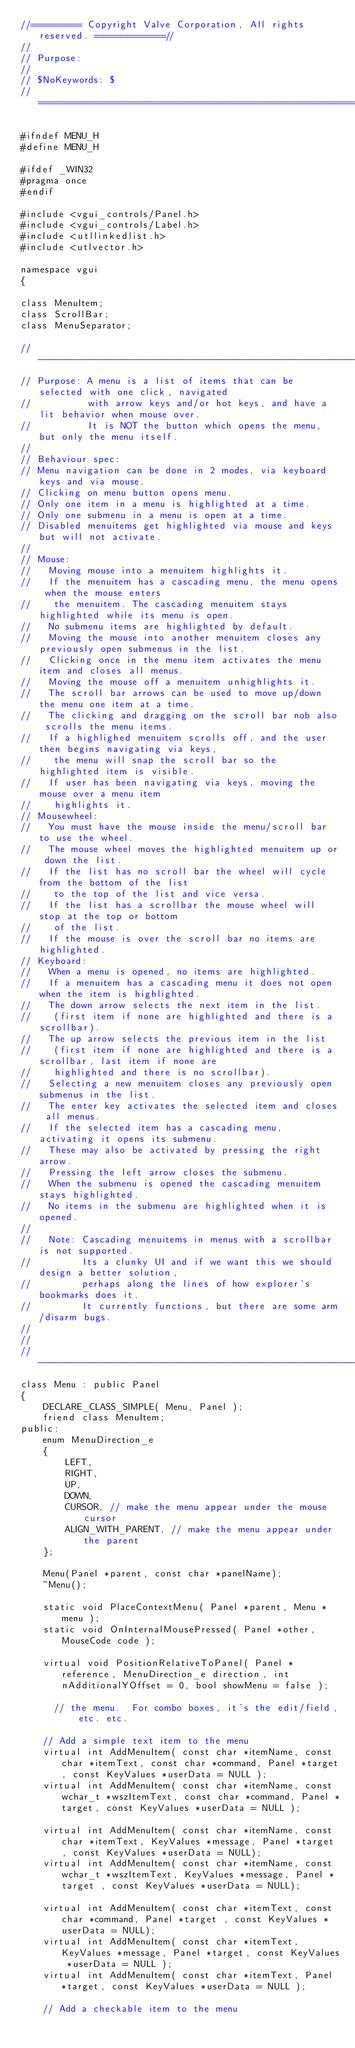Convert code to text. <code><loc_0><loc_0><loc_500><loc_500><_C_>//========= Copyright Valve Corporation, All rights reserved. ============//
//
// Purpose:
//
// $NoKeywords: $
//===========================================================================//

#ifndef MENU_H
#define MENU_H

#ifdef _WIN32
#pragma once
#endif

#include <vgui_controls/Panel.h>
#include <vgui_controls/Label.h>
#include <utllinkedlist.h>
#include <utlvector.h>

namespace vgui
{

class MenuItem;
class ScrollBar;
class MenuSeparator;

//-----------------------------------------------------------------------------
// Purpose: A menu is a list of items that can be selected with one click, navigated
//          with arrow keys and/or hot keys, and have a lit behavior when mouse over.
//          It is NOT the button which opens the menu, but only the menu itself.
//
// Behaviour spec:
// Menu navigation can be done in 2 modes, via keyboard keys and via mouse.
// Clicking on menu button opens menu.
// Only one item in a menu is highlighted at a time.
// Only one submenu in a menu is open at a time.
// Disabled menuitems get highlighted via mouse and keys but will not activate.
//
// Mouse:
//   Moving mouse into a menuitem highlights it.
//   If the menuitem has a cascading menu, the menu opens when the mouse enters
//    the menuitem. The cascading menuitem stays highlighted while its menu is open.
//   No submenu items are highlighted by default.
//   Moving the mouse into another menuitem closes any previously open submenus in the list.
//   Clicking once in the menu item activates the menu item and closes all menus.
//   Moving the mouse off a menuitem unhighlights it.
//   The scroll bar arrows can be used to move up/down the menu one item at a time.
//   The clicking and dragging on the scroll bar nob also scrolls the menu items.
//   If a highlighed menuitem scrolls off, and the user then begins navigating via keys,
//    the menu will snap the scroll bar so the highlighted item is visible.
//   If user has been navigating via keys, moving the mouse over a menu item
//    highlights it.
// Mousewheel:
//   You must have the mouse inside the menu/scroll bar to use the wheel.
//   The mouse wheel moves the highlighted menuitem up or down the list.
//   If the list has no scroll bar the wheel will cycle from the bottom of the list
//    to the top of the list and vice versa.
//   If the list has a scrollbar the mouse wheel will stop at the top or bottom
//    of the list.
//   If the mouse is over the scroll bar no items are highlighted.
// Keyboard:
//   When a menu is opened, no items are highlighted.
//   If a menuitem has a cascading menu it does not open when the item is highlighted.
//   The down arrow selects the next item in the list.
//    (first item if none are highlighted and there is a scrollbar).
//   The up arrow selects the previous item in the list
//    (first item if none are highlighted and there is a scrollbar, last item if none are
//    highlighted and there is no scrollbar).
//   Selecting a new menuitem closes any previously open submenus in the list.
//   The enter key activates the selected item and closes all menus.
//   If the selected item has a cascading menu, activating it opens its submenu.
//   These may also be activated by pressing the right arrow.
//   Pressing the left arrow closes the submenu.
//   When the submenu is opened the cascading menuitem stays highlighted.
//   No items in the submenu are highlighted when it is opened.
//
//   Note: Cascading menuitems in menus with a scrollbar is not supported.
//         Its a clunky UI and if we want this we should design a better solution,
//         perhaps along the lines of how explorer's bookmarks does it.
//         It currently functions, but there are some arm/disarm bugs.
//
//
//-----------------------------------------------------------------------------
class Menu : public Panel
{
    DECLARE_CLASS_SIMPLE( Menu, Panel );
    friend class MenuItem;
public:
    enum MenuDirection_e
    {
        LEFT,
        RIGHT,
        UP,
        DOWN,
        CURSOR, // make the menu appear under the mouse cursor
        ALIGN_WITH_PARENT, // make the menu appear under the parent
    };

    Menu(Panel *parent, const char *panelName);
    ~Menu();

    static void PlaceContextMenu( Panel *parent, Menu *menu );
    static void OnInternalMousePressed( Panel *other, MouseCode code );

    virtual void PositionRelativeToPanel( Panel *reference, MenuDirection_e direction, int nAdditionalYOffset = 0, bool showMenu = false );

      // the menu.  For combo boxes, it's the edit/field, etc. etc.

    // Add a simple text item to the menu
    virtual int AddMenuItem( const char *itemName, const char *itemText, const char *command, Panel *target, const KeyValues *userData = NULL );
    virtual int AddMenuItem( const char *itemName, const wchar_t *wszItemText, const char *command, Panel *target, const KeyValues *userData = NULL );

    virtual int AddMenuItem( const char *itemName, const char *itemText, KeyValues *message, Panel *target , const KeyValues *userData = NULL);
    virtual int AddMenuItem( const char *itemName, const wchar_t *wszItemText, KeyValues *message, Panel *target , const KeyValues *userData = NULL);

    virtual int AddMenuItem( const char *itemText, const char *command, Panel *target , const KeyValues *userData = NULL);
    virtual int AddMenuItem( const char *itemText, KeyValues *message, Panel *target, const KeyValues *userData = NULL );
    virtual int AddMenuItem( const char *itemText, Panel *target, const KeyValues *userData = NULL );

    // Add a checkable item to the menu</code> 